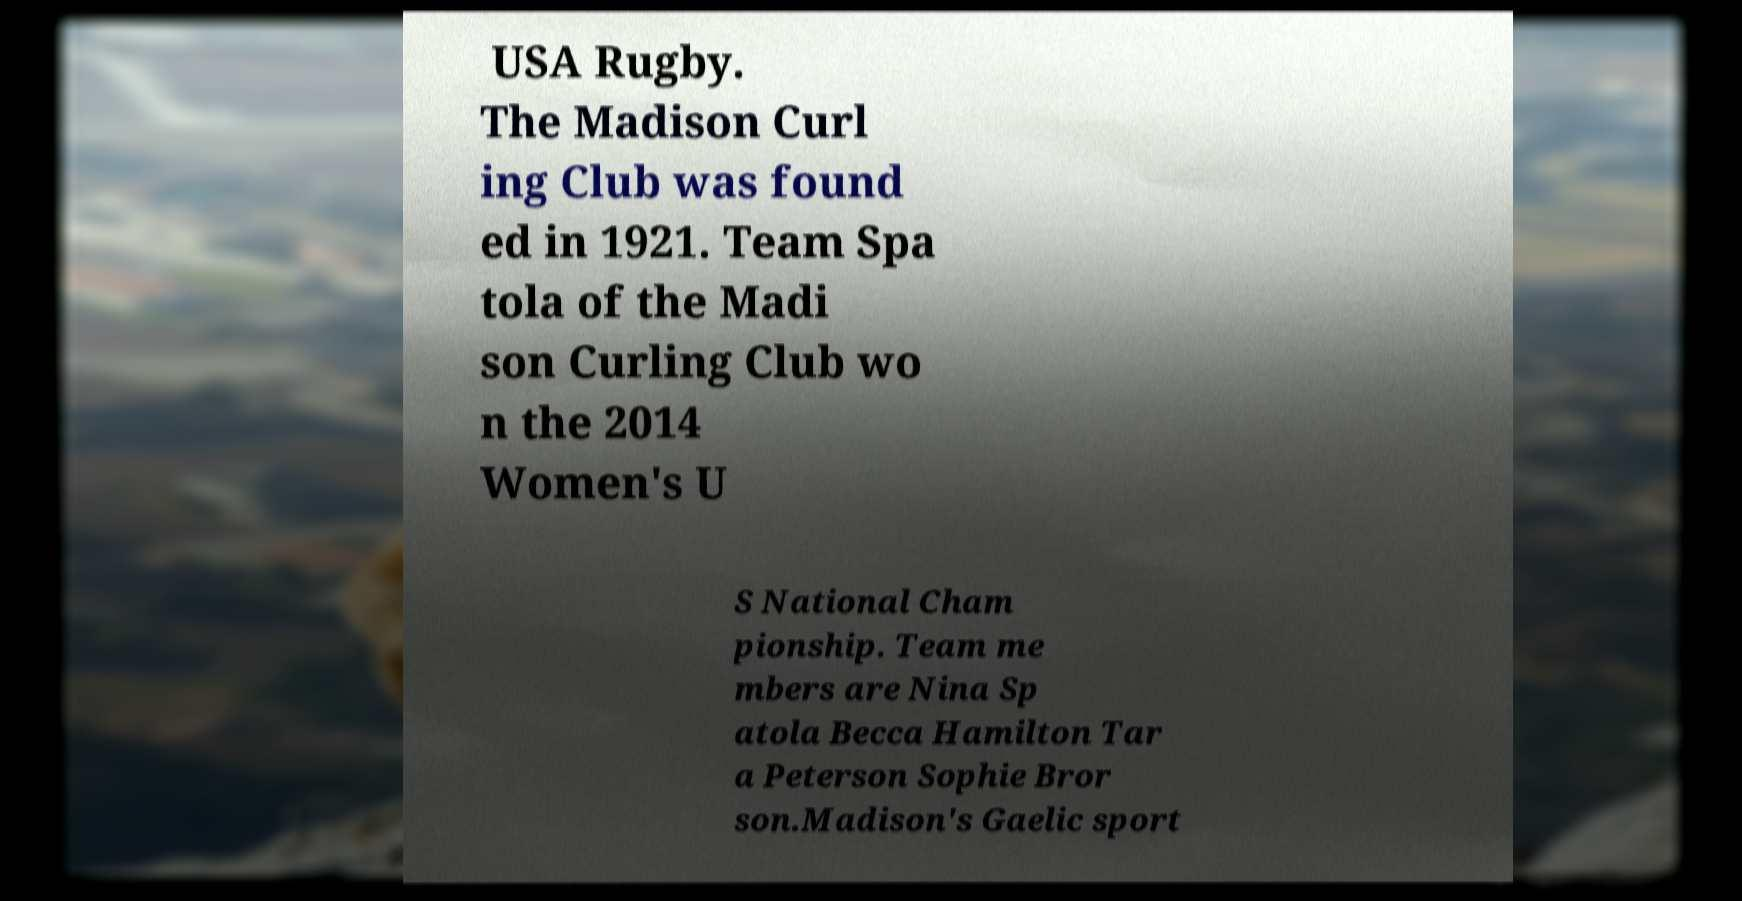What messages or text are displayed in this image? I need them in a readable, typed format. USA Rugby. The Madison Curl ing Club was found ed in 1921. Team Spa tola of the Madi son Curling Club wo n the 2014 Women's U S National Cham pionship. Team me mbers are Nina Sp atola Becca Hamilton Tar a Peterson Sophie Bror son.Madison's Gaelic sport 